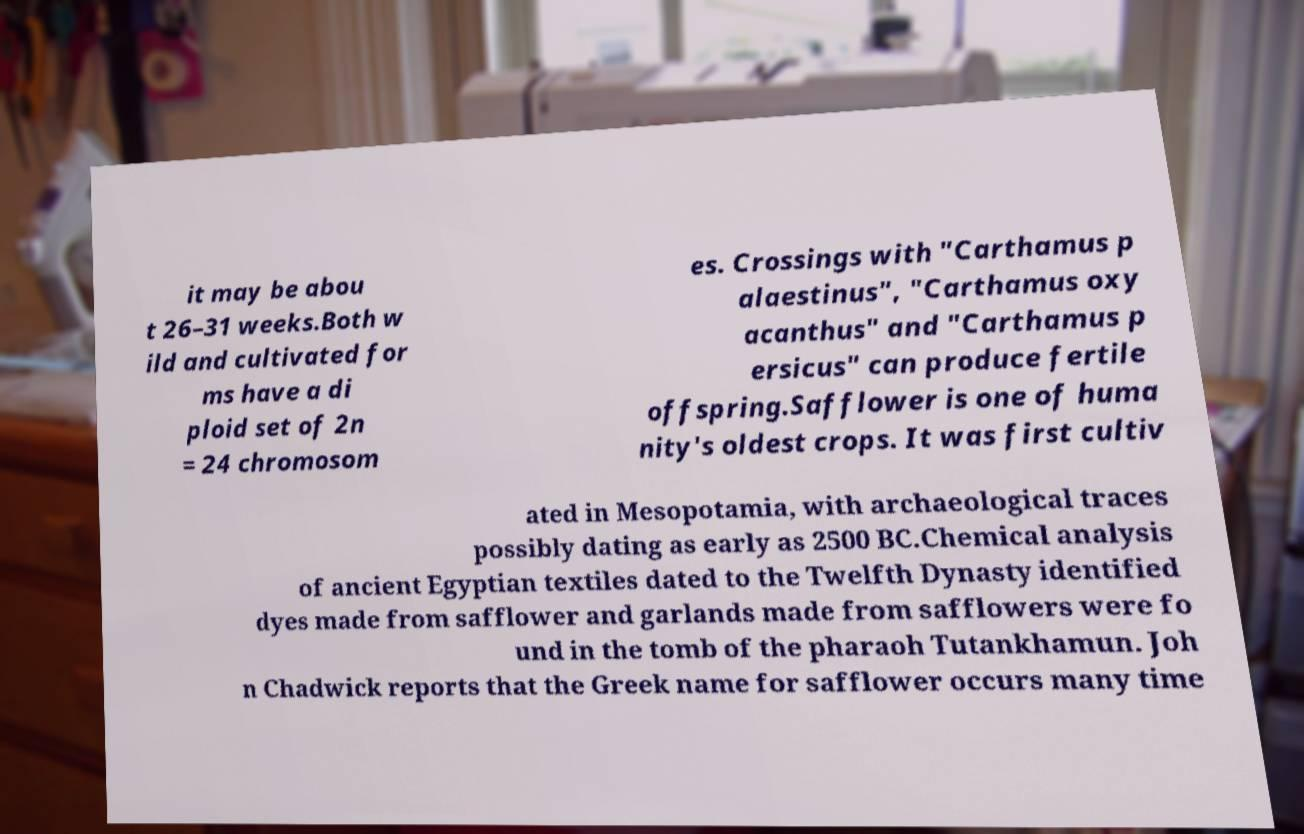There's text embedded in this image that I need extracted. Can you transcribe it verbatim? it may be abou t 26–31 weeks.Both w ild and cultivated for ms have a di ploid set of 2n = 24 chromosom es. Crossings with "Carthamus p alaestinus", "Carthamus oxy acanthus" and "Carthamus p ersicus" can produce fertile offspring.Safflower is one of huma nity's oldest crops. It was first cultiv ated in Mesopotamia, with archaeological traces possibly dating as early as 2500 BC.Chemical analysis of ancient Egyptian textiles dated to the Twelfth Dynasty identified dyes made from safflower and garlands made from safflowers were fo und in the tomb of the pharaoh Tutankhamun. Joh n Chadwick reports that the Greek name for safflower occurs many time 